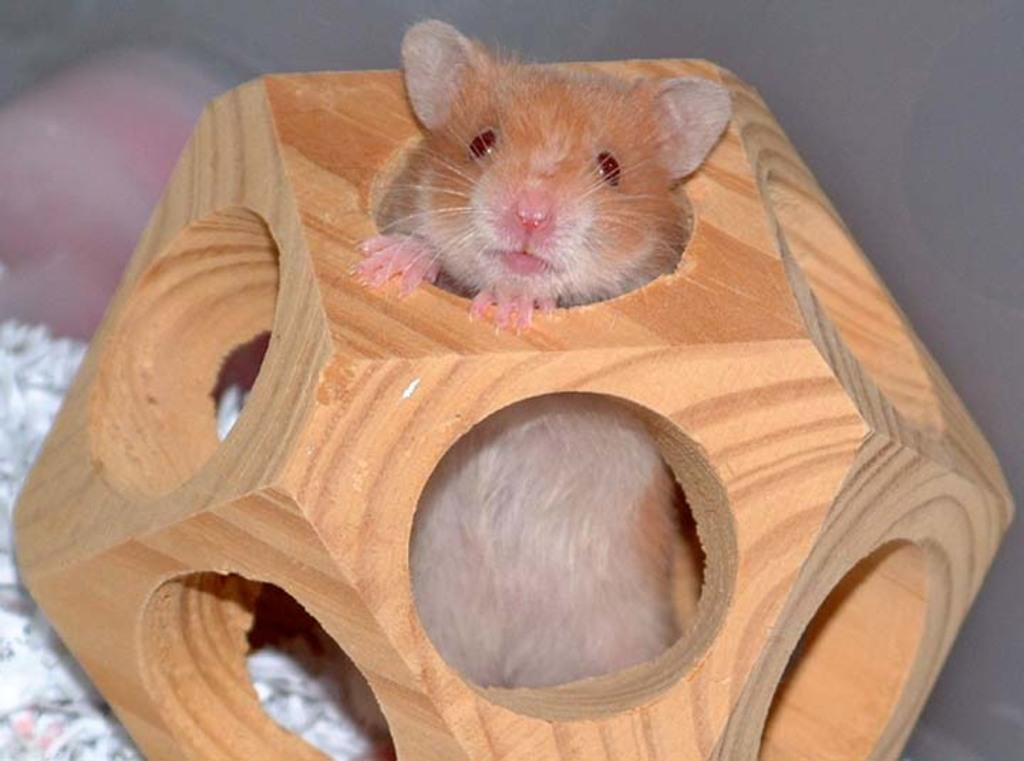What type of animal is present in the image? There is a rat present in the image. Where is the rat located in the image? The rat is inside a wooden box. What type of apple is the rat holding in its paw in the image? There is no apple present in the image, and the rat is not holding anything in its paw. 